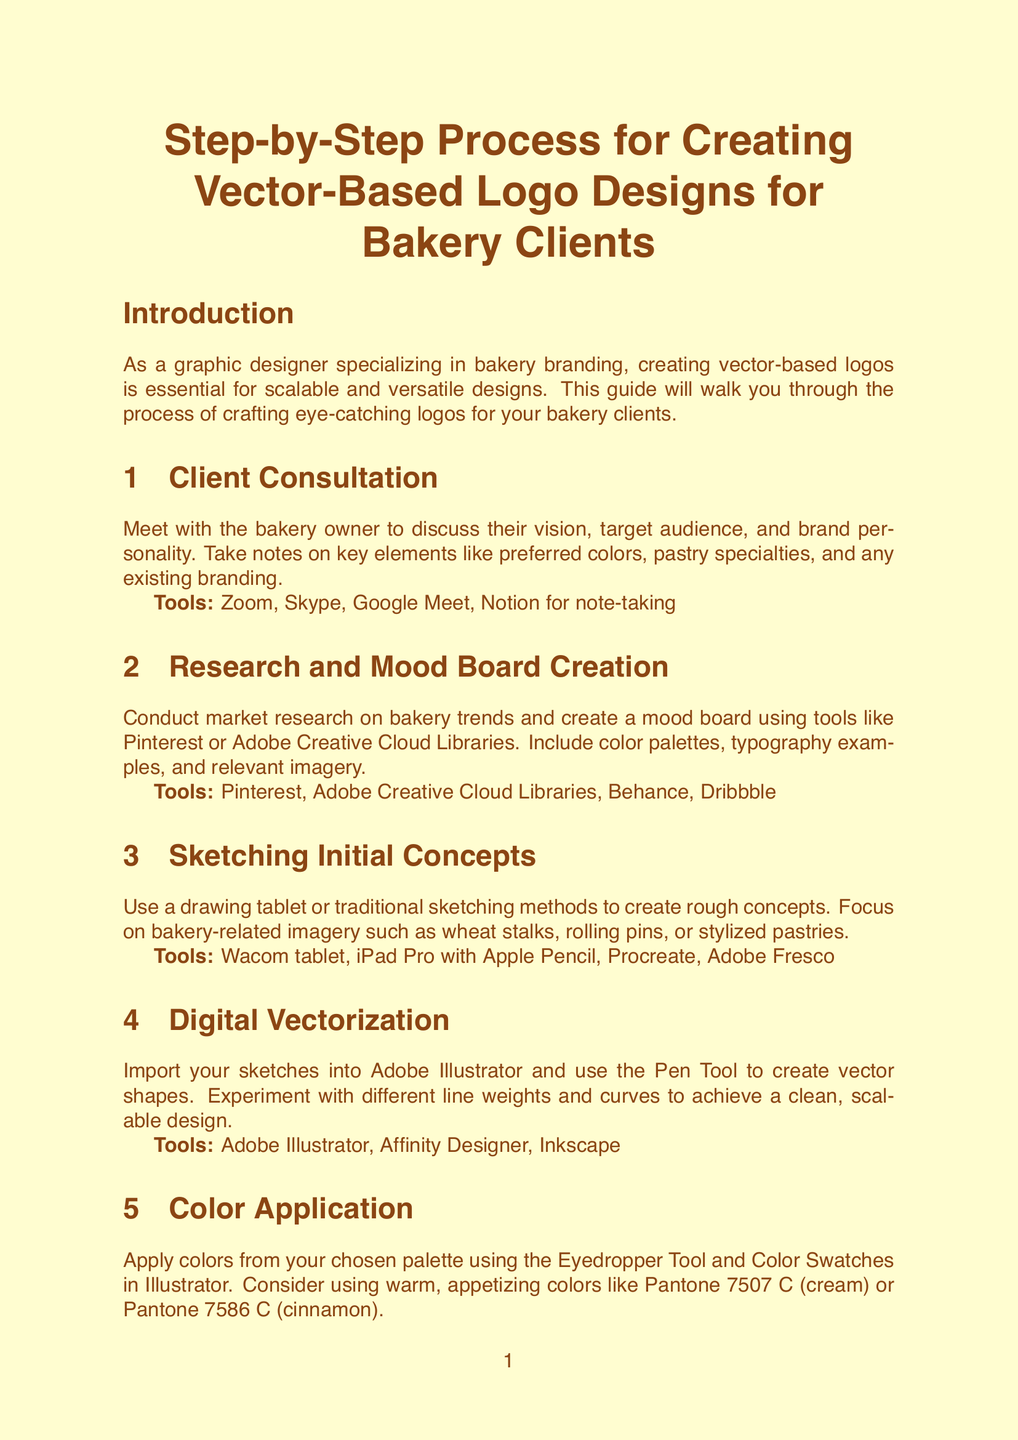What is the first step in the logo design process? The first step in the logo design process is meeting with the bakery owner to discuss their vision, target audience, and brand personality.
Answer: Client Consultation What tools are recommended for mood board creation? The document lists tools such as Pinterest and Adobe Creative Cloud Libraries for creating mood boards.
Answer: Pinterest, Adobe Creative Cloud Libraries Which font pairing is suggested for bakery logos? The document suggests pairing a script font like 'Brusher' with a clean sans-serif like 'Montserrat' for bakery logos.
Answer: Brusher and Montserrat How many formats should final files be prepared in? The manual states that final files should be prepared in various formats including AI, EPS, PDF, PNG, and JPG.
Answer: Five What step involves refining designs based on client feedback? This step focuses on incorporating client feedback and making necessary revisions to the logo design.
Answer: Revisions and Finalization Which tool is recommended for client communication during the finalization process? The document mentions using Slack for client communication when incorporating feedback and making revisions.
Answer: Slack What type of designs does this guide mainly focus on? The guide specifically focuses on creating vector-based logo designs for bakery clients.
Answer: Vector-based logo designs What color modes should be used for digital files? The document recommends using RGB color mode for digital files.
Answer: RGB Which section of the document describes the preparation of a brand guidelines document? The last step discusses preparing a brand guidelines document outlining logo usage and color specifications.
Answer: File Preparation and Delivery 